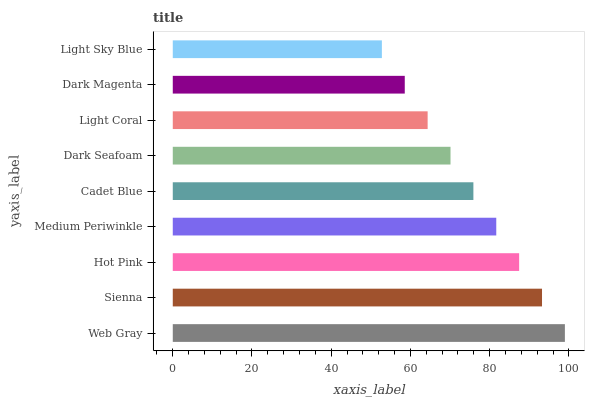Is Light Sky Blue the minimum?
Answer yes or no. Yes. Is Web Gray the maximum?
Answer yes or no. Yes. Is Sienna the minimum?
Answer yes or no. No. Is Sienna the maximum?
Answer yes or no. No. Is Web Gray greater than Sienna?
Answer yes or no. Yes. Is Sienna less than Web Gray?
Answer yes or no. Yes. Is Sienna greater than Web Gray?
Answer yes or no. No. Is Web Gray less than Sienna?
Answer yes or no. No. Is Cadet Blue the high median?
Answer yes or no. Yes. Is Cadet Blue the low median?
Answer yes or no. Yes. Is Dark Magenta the high median?
Answer yes or no. No. Is Medium Periwinkle the low median?
Answer yes or no. No. 